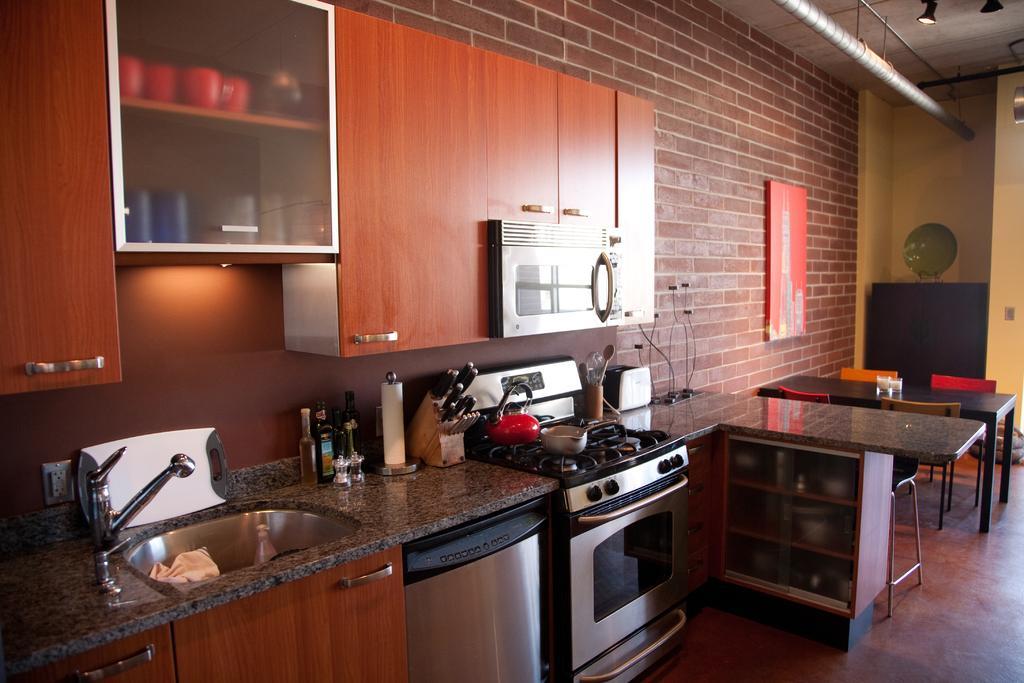Could you give a brief overview of what you see in this image? In this picture I can see the kitchen platform. On the kitchen platform I can see the stove, wash basin, cloth, shampoo bottle, oil bottle, salt bottle, tissue paper, knives, knife holder, bowl and other objects. On the left i can see the cupboards. At the top left i can see the red cups and blue and white glasses which are kept on this cupboard. In the bottom I can see the oven. On the right there are tissue papers on the table, beside that I can see the chairs. There is a painting on the wall. On the top right corner i can see the lights and bikes. In the background there is a television near to the door. 